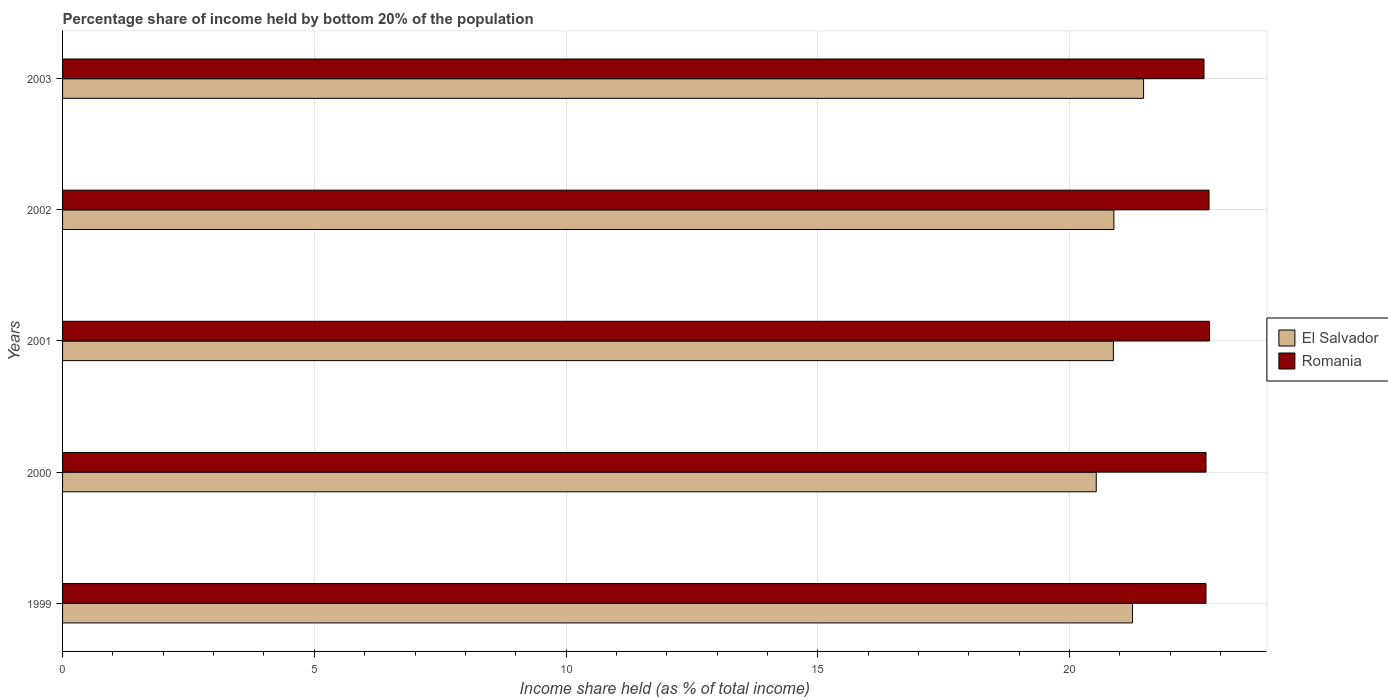How many different coloured bars are there?
Provide a short and direct response. 2. How many groups of bars are there?
Your answer should be very brief. 5. Are the number of bars per tick equal to the number of legend labels?
Provide a succinct answer. Yes. How many bars are there on the 3rd tick from the bottom?
Ensure brevity in your answer.  2. What is the label of the 4th group of bars from the top?
Your answer should be compact. 2000. In how many cases, is the number of bars for a given year not equal to the number of legend labels?
Ensure brevity in your answer.  0. What is the share of income held by bottom 20% of the population in Romania in 1999?
Your answer should be very brief. 22.71. Across all years, what is the maximum share of income held by bottom 20% of the population in Romania?
Your response must be concise. 22.78. Across all years, what is the minimum share of income held by bottom 20% of the population in El Salvador?
Your answer should be very brief. 20.53. What is the total share of income held by bottom 20% of the population in Romania in the graph?
Keep it short and to the point. 113.64. What is the difference between the share of income held by bottom 20% of the population in Romania in 1999 and that in 2001?
Offer a very short reply. -0.07. What is the difference between the share of income held by bottom 20% of the population in El Salvador in 2001 and the share of income held by bottom 20% of the population in Romania in 2003?
Give a very brief answer. -1.8. What is the average share of income held by bottom 20% of the population in Romania per year?
Offer a terse response. 22.73. In the year 1999, what is the difference between the share of income held by bottom 20% of the population in El Salvador and share of income held by bottom 20% of the population in Romania?
Your answer should be compact. -1.46. In how many years, is the share of income held by bottom 20% of the population in Romania greater than 1 %?
Make the answer very short. 5. What is the ratio of the share of income held by bottom 20% of the population in El Salvador in 1999 to that in 2003?
Ensure brevity in your answer.  0.99. Is the share of income held by bottom 20% of the population in Romania in 1999 less than that in 2003?
Make the answer very short. No. What is the difference between the highest and the second highest share of income held by bottom 20% of the population in Romania?
Your answer should be very brief. 0.01. What is the difference between the highest and the lowest share of income held by bottom 20% of the population in El Salvador?
Offer a very short reply. 0.94. In how many years, is the share of income held by bottom 20% of the population in El Salvador greater than the average share of income held by bottom 20% of the population in El Salvador taken over all years?
Offer a terse response. 2. Is the sum of the share of income held by bottom 20% of the population in El Salvador in 2000 and 2002 greater than the maximum share of income held by bottom 20% of the population in Romania across all years?
Make the answer very short. Yes. What does the 2nd bar from the top in 2001 represents?
Keep it short and to the point. El Salvador. What does the 2nd bar from the bottom in 2001 represents?
Give a very brief answer. Romania. How many bars are there?
Keep it short and to the point. 10. How many years are there in the graph?
Make the answer very short. 5. What is the difference between two consecutive major ticks on the X-axis?
Provide a succinct answer. 5. Are the values on the major ticks of X-axis written in scientific E-notation?
Your answer should be compact. No. Does the graph contain any zero values?
Ensure brevity in your answer.  No. Does the graph contain grids?
Offer a terse response. Yes. How are the legend labels stacked?
Your answer should be very brief. Vertical. What is the title of the graph?
Offer a terse response. Percentage share of income held by bottom 20% of the population. What is the label or title of the X-axis?
Your response must be concise. Income share held (as % of total income). What is the Income share held (as % of total income) of El Salvador in 1999?
Keep it short and to the point. 21.25. What is the Income share held (as % of total income) in Romania in 1999?
Provide a succinct answer. 22.71. What is the Income share held (as % of total income) of El Salvador in 2000?
Give a very brief answer. 20.53. What is the Income share held (as % of total income) in Romania in 2000?
Your answer should be compact. 22.71. What is the Income share held (as % of total income) in El Salvador in 2001?
Your response must be concise. 20.87. What is the Income share held (as % of total income) of Romania in 2001?
Give a very brief answer. 22.78. What is the Income share held (as % of total income) of El Salvador in 2002?
Provide a short and direct response. 20.88. What is the Income share held (as % of total income) of Romania in 2002?
Keep it short and to the point. 22.77. What is the Income share held (as % of total income) in El Salvador in 2003?
Offer a very short reply. 21.47. What is the Income share held (as % of total income) of Romania in 2003?
Make the answer very short. 22.67. Across all years, what is the maximum Income share held (as % of total income) of El Salvador?
Your answer should be very brief. 21.47. Across all years, what is the maximum Income share held (as % of total income) in Romania?
Your answer should be very brief. 22.78. Across all years, what is the minimum Income share held (as % of total income) in El Salvador?
Offer a terse response. 20.53. Across all years, what is the minimum Income share held (as % of total income) of Romania?
Provide a short and direct response. 22.67. What is the total Income share held (as % of total income) in El Salvador in the graph?
Provide a succinct answer. 105. What is the total Income share held (as % of total income) in Romania in the graph?
Your answer should be compact. 113.64. What is the difference between the Income share held (as % of total income) of El Salvador in 1999 and that in 2000?
Keep it short and to the point. 0.72. What is the difference between the Income share held (as % of total income) in Romania in 1999 and that in 2000?
Provide a short and direct response. 0. What is the difference between the Income share held (as % of total income) of El Salvador in 1999 and that in 2001?
Offer a very short reply. 0.38. What is the difference between the Income share held (as % of total income) of Romania in 1999 and that in 2001?
Your response must be concise. -0.07. What is the difference between the Income share held (as % of total income) of El Salvador in 1999 and that in 2002?
Your answer should be very brief. 0.37. What is the difference between the Income share held (as % of total income) in Romania in 1999 and that in 2002?
Keep it short and to the point. -0.06. What is the difference between the Income share held (as % of total income) of El Salvador in 1999 and that in 2003?
Provide a short and direct response. -0.22. What is the difference between the Income share held (as % of total income) in Romania in 1999 and that in 2003?
Give a very brief answer. 0.04. What is the difference between the Income share held (as % of total income) of El Salvador in 2000 and that in 2001?
Your answer should be very brief. -0.34. What is the difference between the Income share held (as % of total income) of Romania in 2000 and that in 2001?
Make the answer very short. -0.07. What is the difference between the Income share held (as % of total income) in El Salvador in 2000 and that in 2002?
Ensure brevity in your answer.  -0.35. What is the difference between the Income share held (as % of total income) in Romania in 2000 and that in 2002?
Ensure brevity in your answer.  -0.06. What is the difference between the Income share held (as % of total income) of El Salvador in 2000 and that in 2003?
Ensure brevity in your answer.  -0.94. What is the difference between the Income share held (as % of total income) in El Salvador in 2001 and that in 2002?
Provide a succinct answer. -0.01. What is the difference between the Income share held (as % of total income) in Romania in 2001 and that in 2003?
Offer a very short reply. 0.11. What is the difference between the Income share held (as % of total income) in El Salvador in 2002 and that in 2003?
Offer a terse response. -0.59. What is the difference between the Income share held (as % of total income) in Romania in 2002 and that in 2003?
Provide a succinct answer. 0.1. What is the difference between the Income share held (as % of total income) of El Salvador in 1999 and the Income share held (as % of total income) of Romania in 2000?
Offer a very short reply. -1.46. What is the difference between the Income share held (as % of total income) in El Salvador in 1999 and the Income share held (as % of total income) in Romania in 2001?
Your answer should be compact. -1.53. What is the difference between the Income share held (as % of total income) in El Salvador in 1999 and the Income share held (as % of total income) in Romania in 2002?
Offer a terse response. -1.52. What is the difference between the Income share held (as % of total income) of El Salvador in 1999 and the Income share held (as % of total income) of Romania in 2003?
Provide a short and direct response. -1.42. What is the difference between the Income share held (as % of total income) in El Salvador in 2000 and the Income share held (as % of total income) in Romania in 2001?
Offer a terse response. -2.25. What is the difference between the Income share held (as % of total income) in El Salvador in 2000 and the Income share held (as % of total income) in Romania in 2002?
Offer a terse response. -2.24. What is the difference between the Income share held (as % of total income) in El Salvador in 2000 and the Income share held (as % of total income) in Romania in 2003?
Offer a very short reply. -2.14. What is the difference between the Income share held (as % of total income) of El Salvador in 2002 and the Income share held (as % of total income) of Romania in 2003?
Keep it short and to the point. -1.79. What is the average Income share held (as % of total income) in Romania per year?
Ensure brevity in your answer.  22.73. In the year 1999, what is the difference between the Income share held (as % of total income) of El Salvador and Income share held (as % of total income) of Romania?
Your answer should be very brief. -1.46. In the year 2000, what is the difference between the Income share held (as % of total income) in El Salvador and Income share held (as % of total income) in Romania?
Provide a short and direct response. -2.18. In the year 2001, what is the difference between the Income share held (as % of total income) of El Salvador and Income share held (as % of total income) of Romania?
Keep it short and to the point. -1.91. In the year 2002, what is the difference between the Income share held (as % of total income) of El Salvador and Income share held (as % of total income) of Romania?
Keep it short and to the point. -1.89. In the year 2003, what is the difference between the Income share held (as % of total income) of El Salvador and Income share held (as % of total income) of Romania?
Ensure brevity in your answer.  -1.2. What is the ratio of the Income share held (as % of total income) of El Salvador in 1999 to that in 2000?
Provide a succinct answer. 1.04. What is the ratio of the Income share held (as % of total income) in Romania in 1999 to that in 2000?
Your answer should be compact. 1. What is the ratio of the Income share held (as % of total income) of El Salvador in 1999 to that in 2001?
Give a very brief answer. 1.02. What is the ratio of the Income share held (as % of total income) in El Salvador in 1999 to that in 2002?
Offer a terse response. 1.02. What is the ratio of the Income share held (as % of total income) in Romania in 1999 to that in 2003?
Give a very brief answer. 1. What is the ratio of the Income share held (as % of total income) of El Salvador in 2000 to that in 2001?
Your answer should be compact. 0.98. What is the ratio of the Income share held (as % of total income) of El Salvador in 2000 to that in 2002?
Offer a very short reply. 0.98. What is the ratio of the Income share held (as % of total income) in El Salvador in 2000 to that in 2003?
Your answer should be very brief. 0.96. What is the ratio of the Income share held (as % of total income) of El Salvador in 2001 to that in 2003?
Your answer should be compact. 0.97. What is the ratio of the Income share held (as % of total income) of Romania in 2001 to that in 2003?
Your response must be concise. 1. What is the ratio of the Income share held (as % of total income) in El Salvador in 2002 to that in 2003?
Give a very brief answer. 0.97. What is the difference between the highest and the second highest Income share held (as % of total income) in El Salvador?
Make the answer very short. 0.22. What is the difference between the highest and the second highest Income share held (as % of total income) of Romania?
Offer a terse response. 0.01. What is the difference between the highest and the lowest Income share held (as % of total income) of El Salvador?
Give a very brief answer. 0.94. What is the difference between the highest and the lowest Income share held (as % of total income) of Romania?
Your response must be concise. 0.11. 